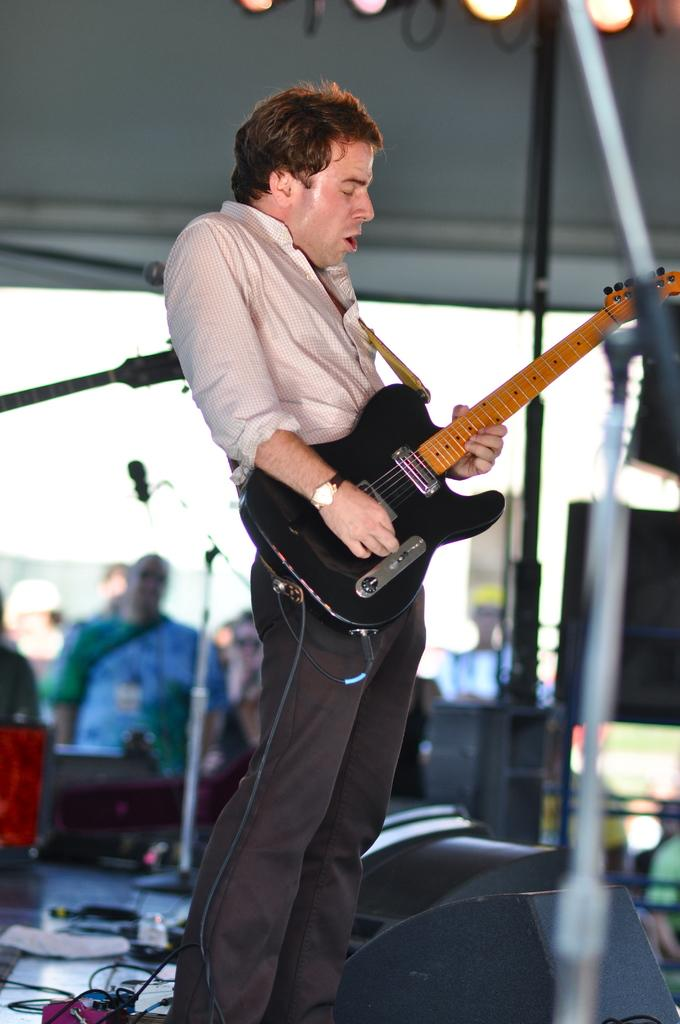What is the main subject of the image? There is a man in the image. What is the man holding in his hand? The man is holding a guitar in his hand. Can you describe the background of the image? The background of the image is blurry. What type of animal can be seen grazing in the field in the image? There is no animal or field present in the image; it features a man holding a guitar with a blurry background. 